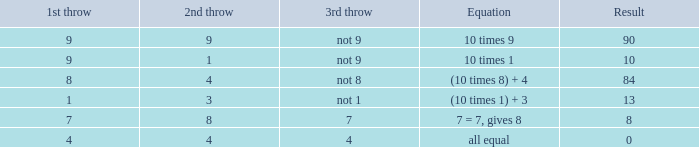Parse the full table. {'header': ['1st throw', '2nd throw', '3rd throw', 'Equation', 'Result'], 'rows': [['9', '9', 'not 9', '10 times 9', '90'], ['9', '1', 'not 9', '10 times 1', '10'], ['8', '4', 'not 8', '(10 times 8) + 4', '84'], ['1', '3', 'not 1', '(10 times 1) + 3', '13'], ['7', '8', '7', '7 = 7, gives 8', '8'], ['4', '4', '4', 'all equal', '0']]} If the equation is all equal, what is the 3rd throw? 4.0. 